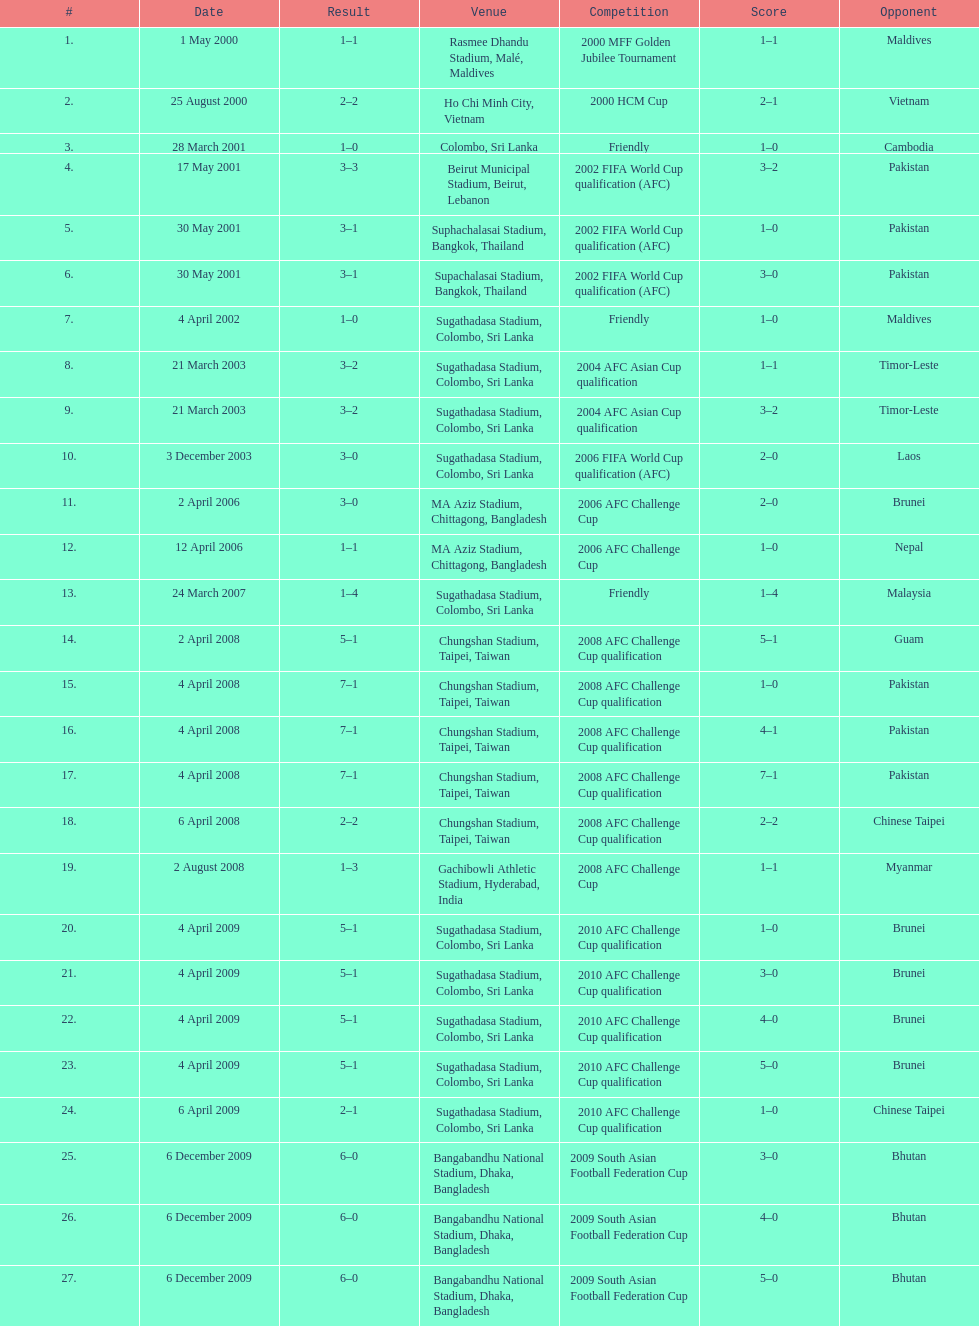What was the total number of goals score in the sri lanka - malaysia game of march 24, 2007? 5. 